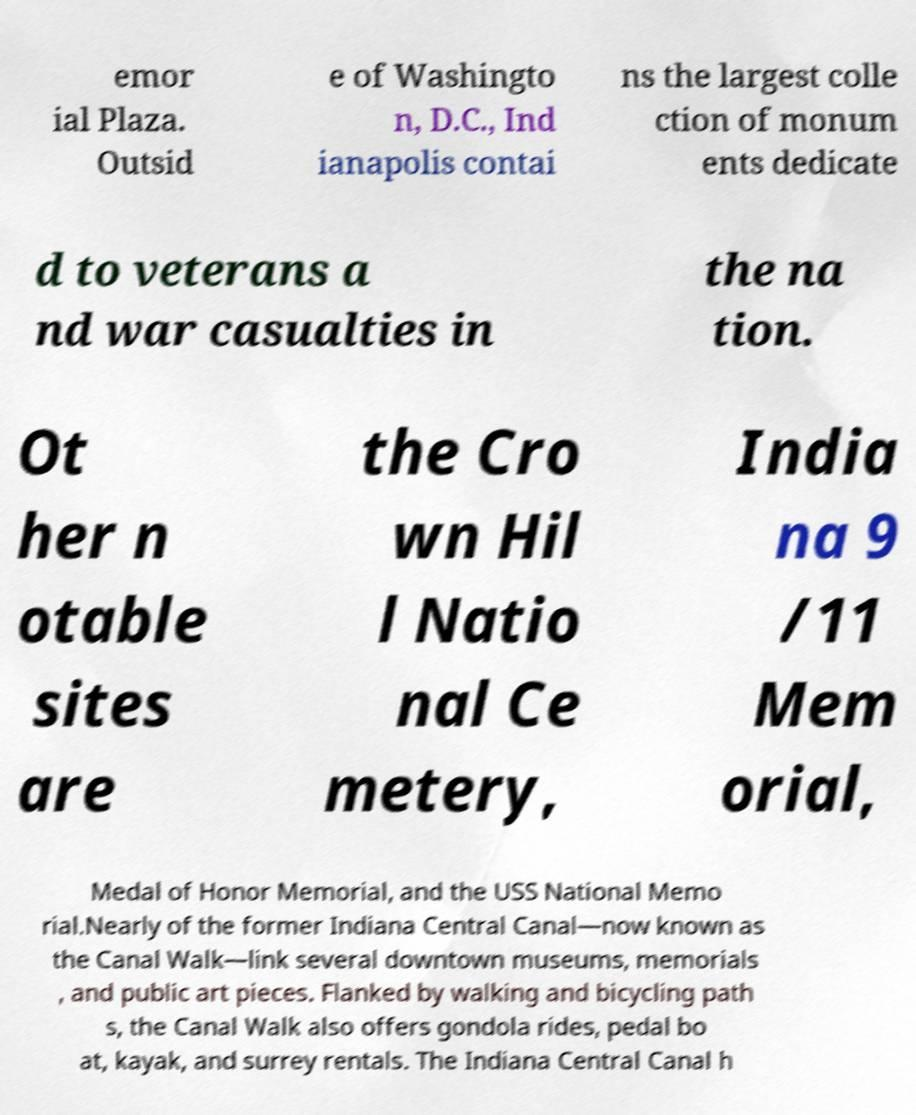There's text embedded in this image that I need extracted. Can you transcribe it verbatim? emor ial Plaza. Outsid e of Washingto n, D.C., Ind ianapolis contai ns the largest colle ction of monum ents dedicate d to veterans a nd war casualties in the na tion. Ot her n otable sites are the Cro wn Hil l Natio nal Ce metery, India na 9 /11 Mem orial, Medal of Honor Memorial, and the USS National Memo rial.Nearly of the former Indiana Central Canal—now known as the Canal Walk—link several downtown museums, memorials , and public art pieces. Flanked by walking and bicycling path s, the Canal Walk also offers gondola rides, pedal bo at, kayak, and surrey rentals. The Indiana Central Canal h 